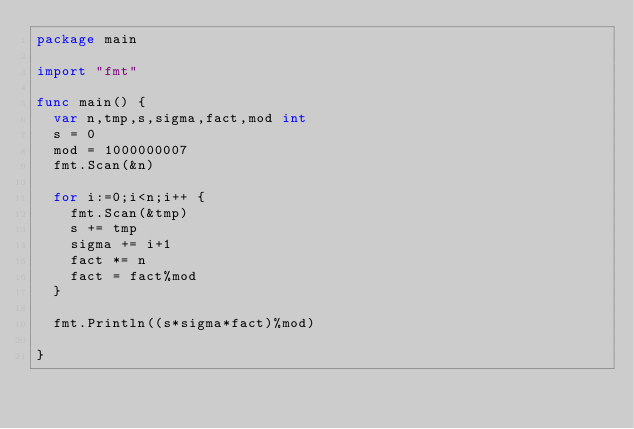<code> <loc_0><loc_0><loc_500><loc_500><_Go_>package main

import "fmt"

func main() {
  var n,tmp,s,sigma,fact,mod int
  s = 0
  mod = 1000000007
  fmt.Scan(&n)
  
  for i:=0;i<n;i++ {
    fmt.Scan(&tmp)
    s += tmp
    sigma += i+1
    fact *= n
    fact = fact%mod
  }
  
  fmt.Println((s*sigma*fact)%mod)
  
}
</code> 